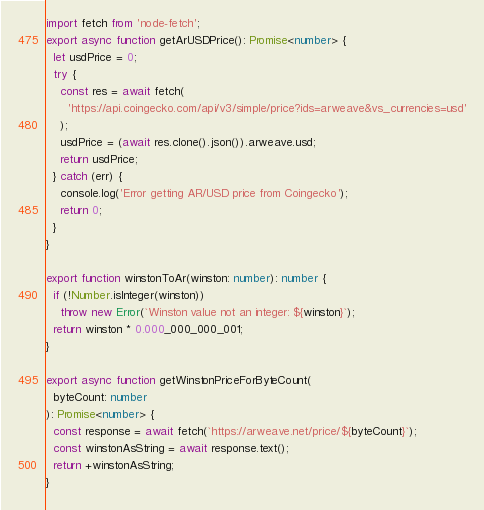<code> <loc_0><loc_0><loc_500><loc_500><_TypeScript_>import fetch from 'node-fetch';
export async function getArUSDPrice(): Promise<number> {
  let usdPrice = 0;
  try {
    const res = await fetch(
      'https://api.coingecko.com/api/v3/simple/price?ids=arweave&vs_currencies=usd'
    );
    usdPrice = (await res.clone().json()).arweave.usd;
    return usdPrice;
  } catch (err) {
    console.log('Error getting AR/USD price from Coingecko');
    return 0;
  }
}

export function winstonToAr(winston: number): number {
  if (!Number.isInteger(winston))
    throw new Error(`Winston value not an integer: ${winston}`);
  return winston * 0.000_000_000_001;
}

export async function getWinstonPriceForByteCount(
  byteCount: number
): Promise<number> {
  const response = await fetch(`https://arweave.net/price/${byteCount}`);
  const winstonAsString = await response.text();
  return +winstonAsString;
}
</code> 